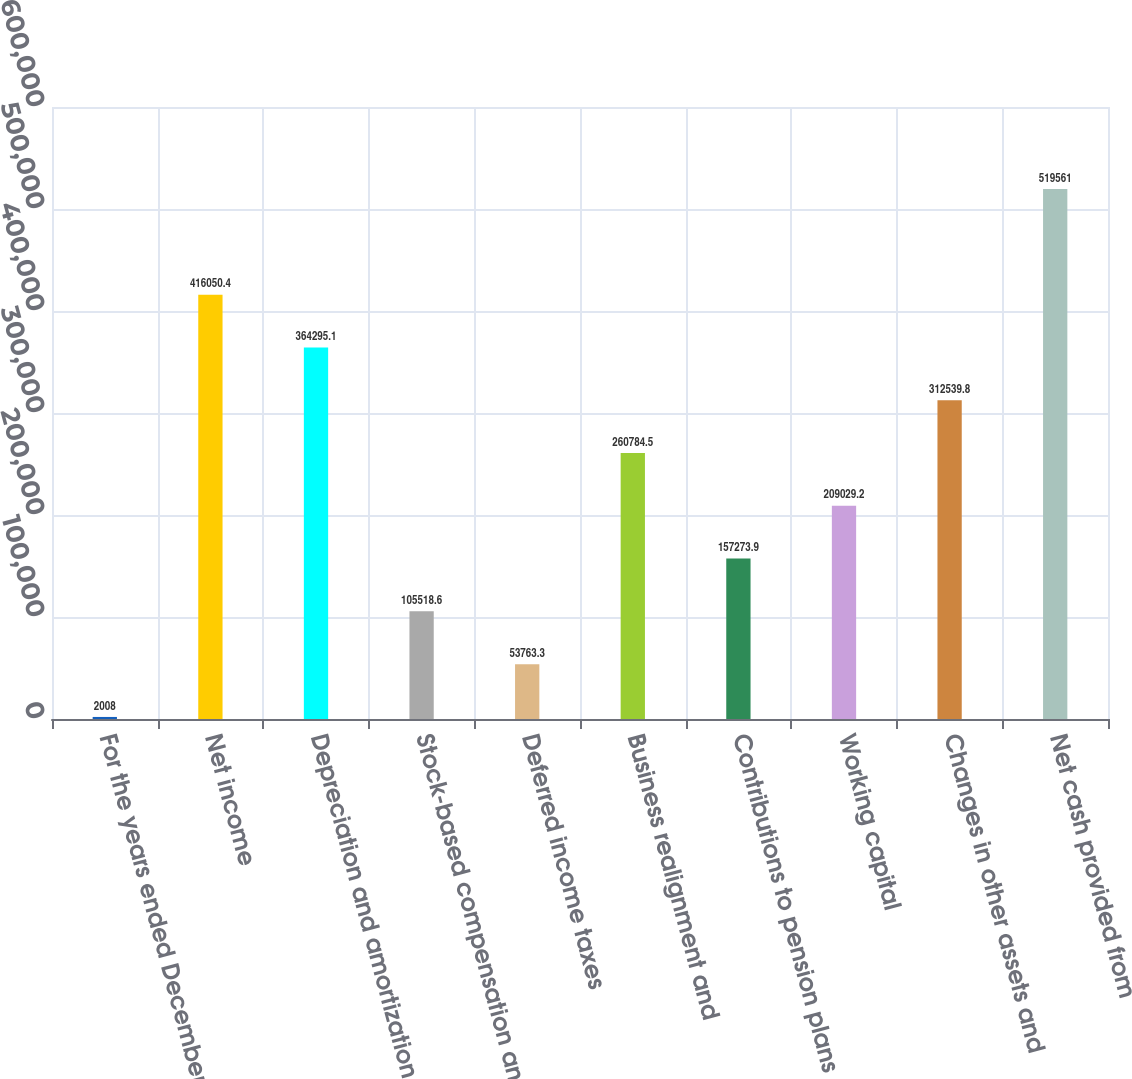Convert chart to OTSL. <chart><loc_0><loc_0><loc_500><loc_500><bar_chart><fcel>For the years ended December<fcel>Net income<fcel>Depreciation and amortization<fcel>Stock-based compensation and<fcel>Deferred income taxes<fcel>Business realignment and<fcel>Contributions to pension plans<fcel>Working capital<fcel>Changes in other assets and<fcel>Net cash provided from<nl><fcel>2008<fcel>416050<fcel>364295<fcel>105519<fcel>53763.3<fcel>260784<fcel>157274<fcel>209029<fcel>312540<fcel>519561<nl></chart> 